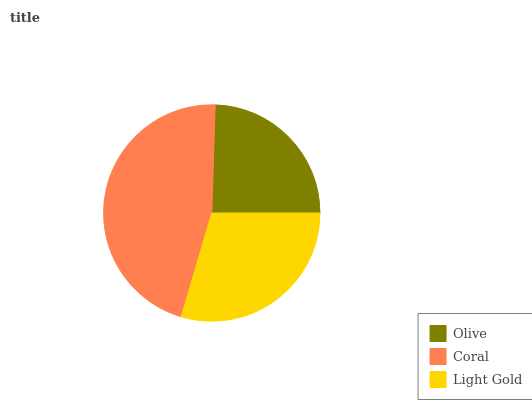Is Olive the minimum?
Answer yes or no. Yes. Is Coral the maximum?
Answer yes or no. Yes. Is Light Gold the minimum?
Answer yes or no. No. Is Light Gold the maximum?
Answer yes or no. No. Is Coral greater than Light Gold?
Answer yes or no. Yes. Is Light Gold less than Coral?
Answer yes or no. Yes. Is Light Gold greater than Coral?
Answer yes or no. No. Is Coral less than Light Gold?
Answer yes or no. No. Is Light Gold the high median?
Answer yes or no. Yes. Is Light Gold the low median?
Answer yes or no. Yes. Is Olive the high median?
Answer yes or no. No. Is Olive the low median?
Answer yes or no. No. 